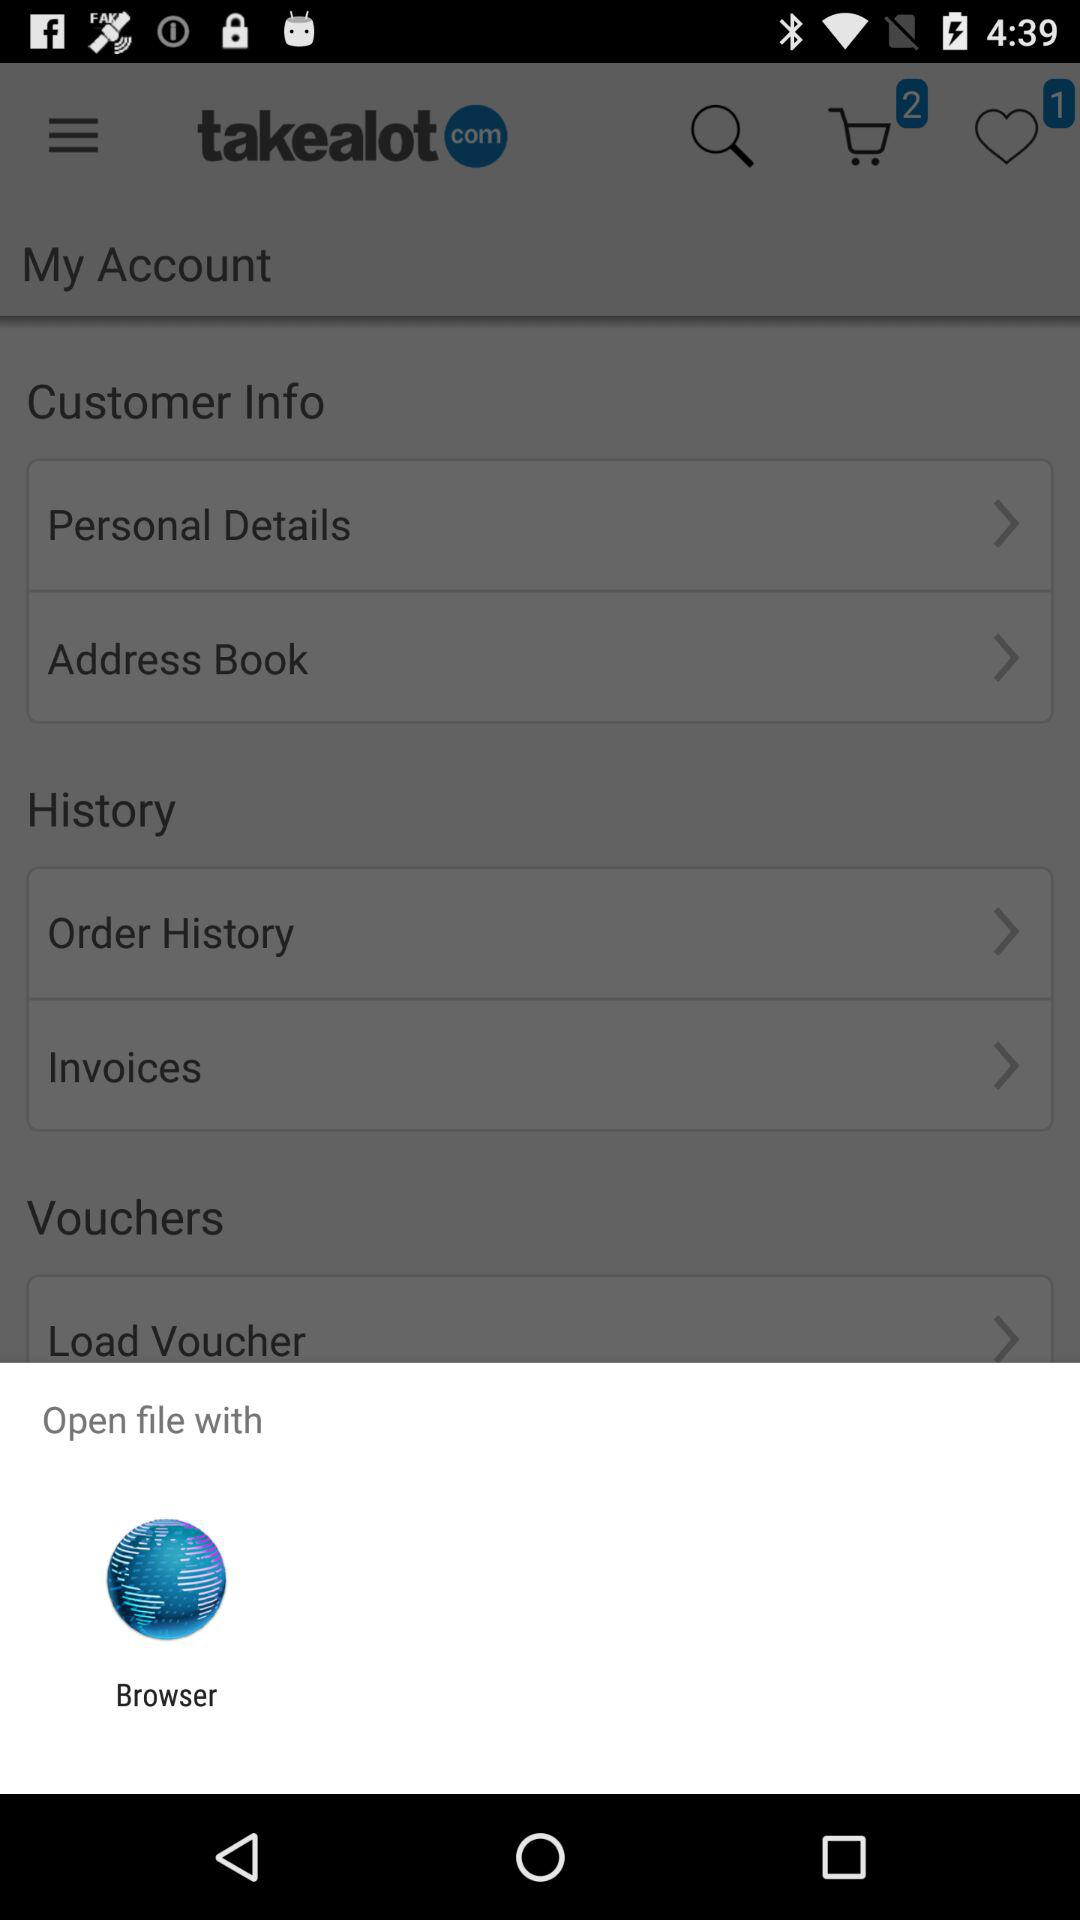How can I open the file? You can open the file through a browser. 